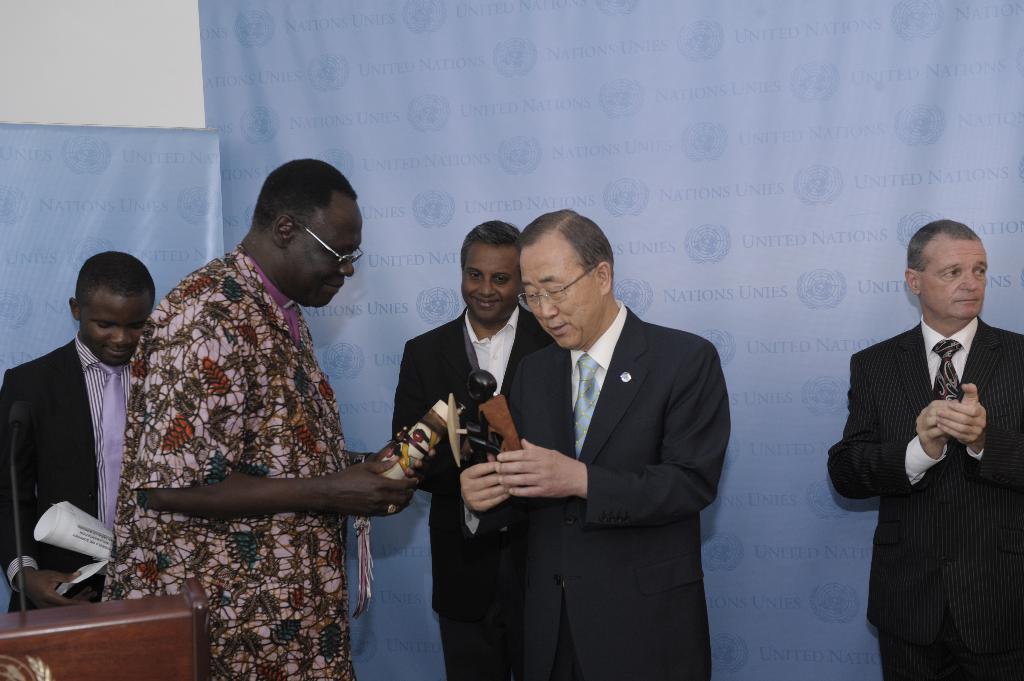Please provide a concise description of this image. In this image I can see few persons wearing black colored blazers are standing and a person wearing colorful dress is standing. I can see two persons holding few objects in their hands, a podium, and microphone and few blue colored banners behind them. 